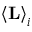Convert formula to latex. <formula><loc_0><loc_0><loc_500><loc_500>\left < L \right > _ { i }</formula> 